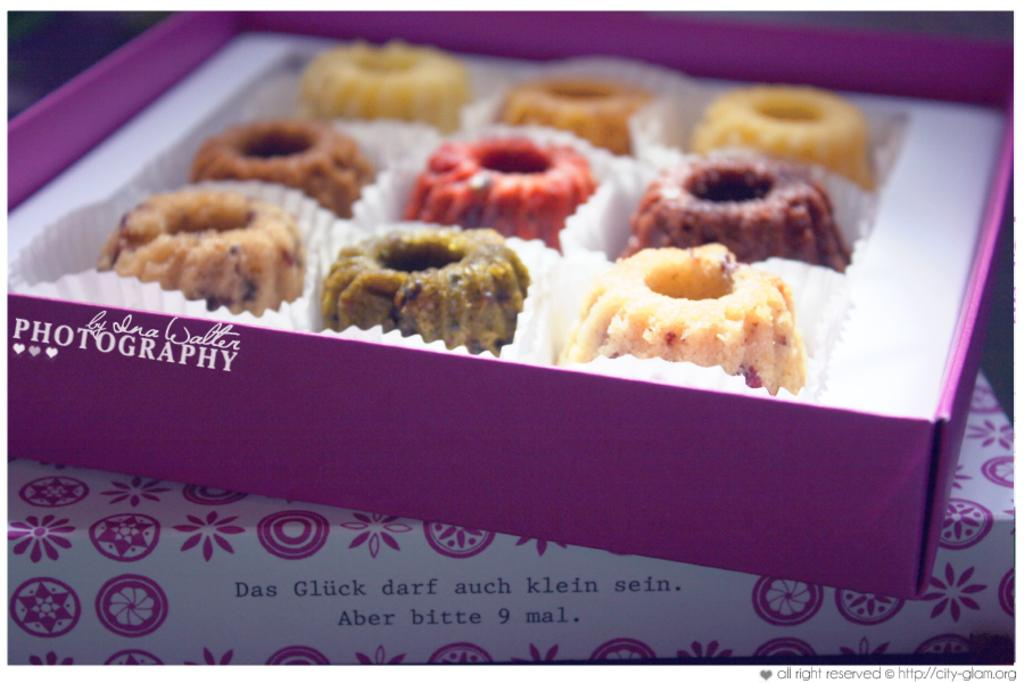What is inside the box that is visible in the image? The box contains cookies. Where is the box located in the image? The box is placed on a table. What else can be seen on the table in the image? There is a colorful cloth on the table. What type of button can be seen on the branch in the image? There is no button or branch present in the image; it only features a box, cookies, a table, and a colorful cloth. 